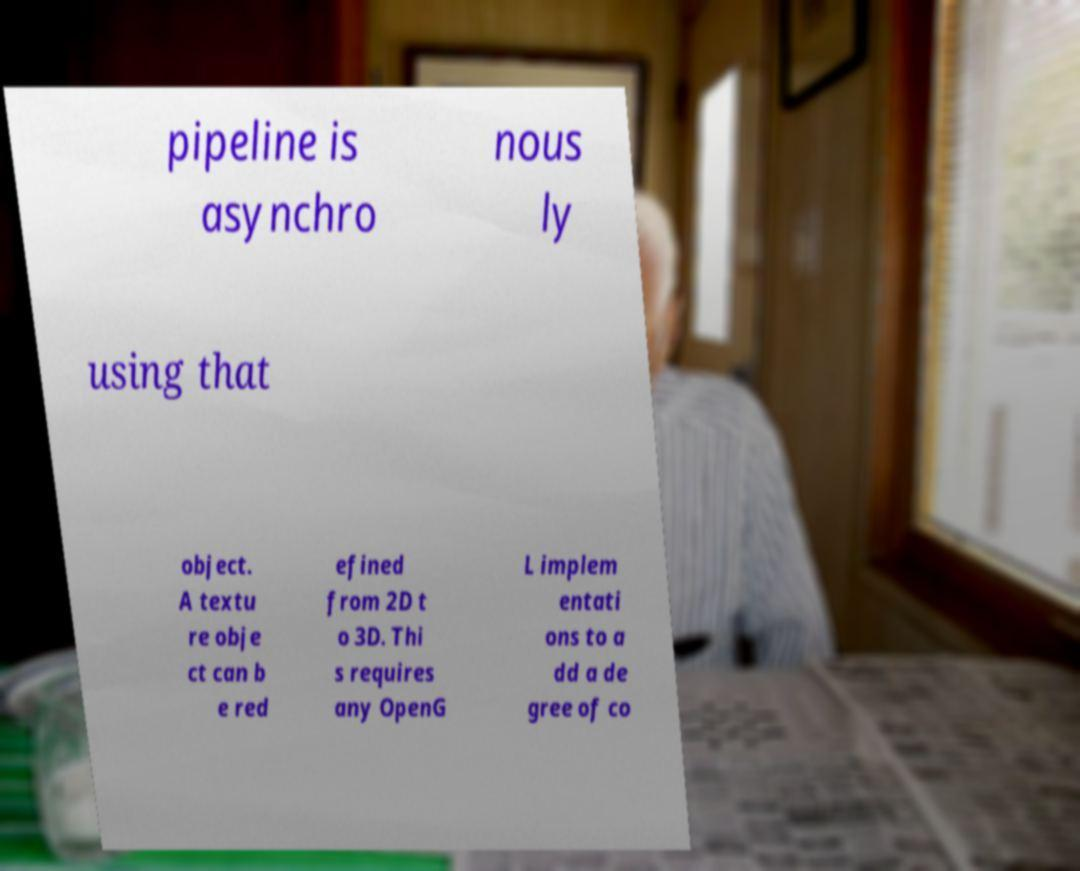Can you read and provide the text displayed in the image?This photo seems to have some interesting text. Can you extract and type it out for me? pipeline is asynchro nous ly using that object. A textu re obje ct can b e red efined from 2D t o 3D. Thi s requires any OpenG L implem entati ons to a dd a de gree of co 